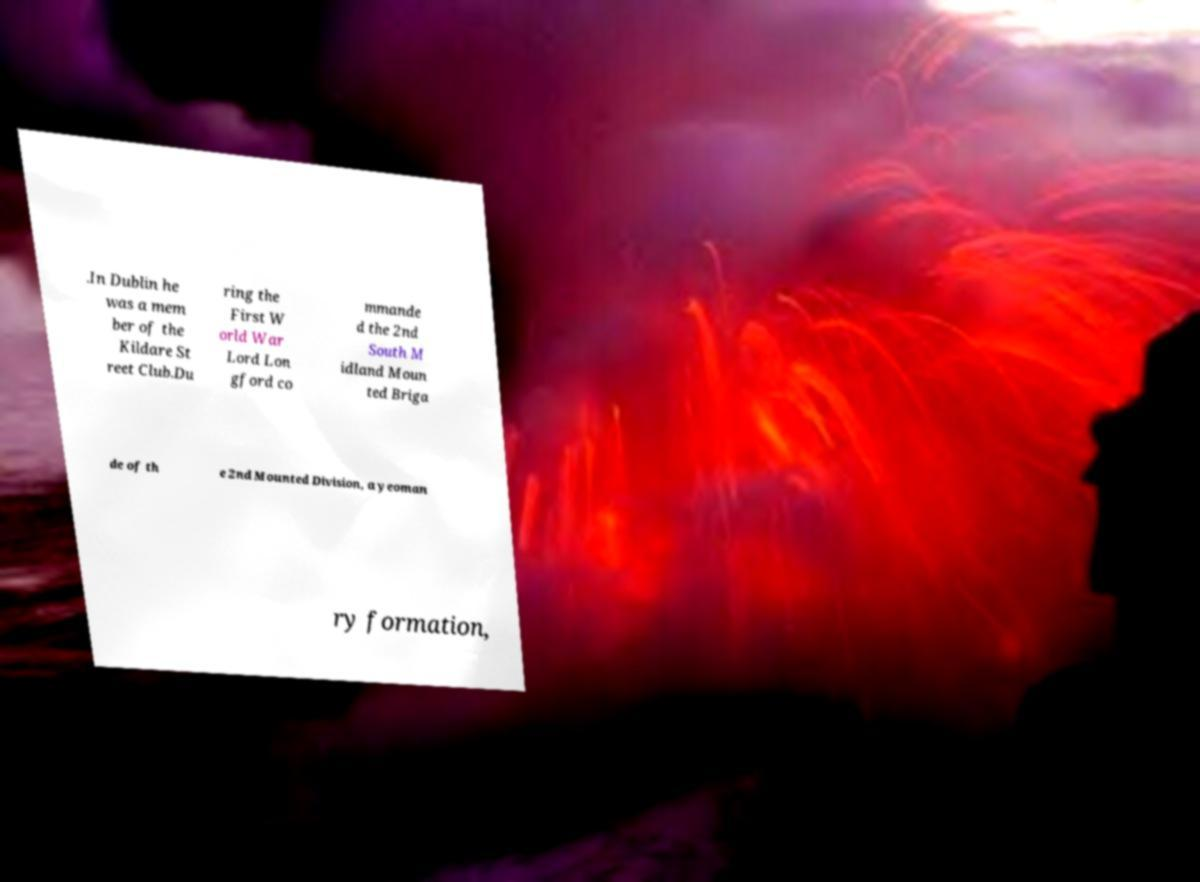Please read and relay the text visible in this image. What does it say? .In Dublin he was a mem ber of the Kildare St reet Club.Du ring the First W orld War Lord Lon gford co mmande d the 2nd South M idland Moun ted Briga de of th e 2nd Mounted Division, a yeoman ry formation, 